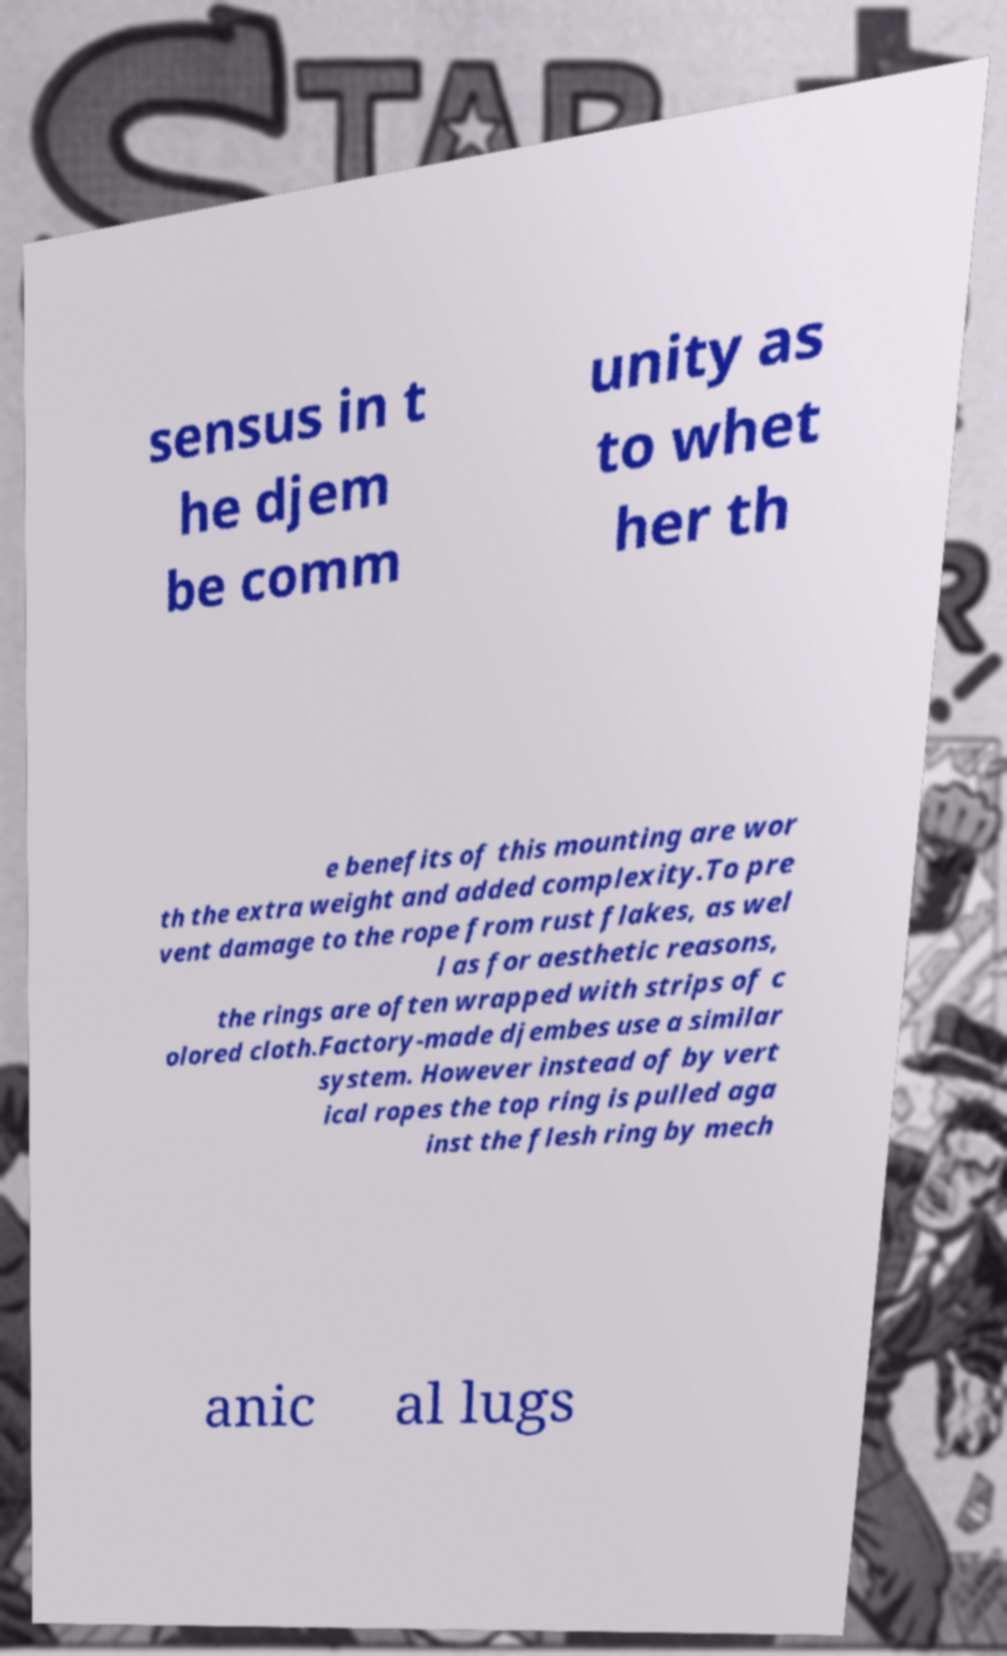Could you assist in decoding the text presented in this image and type it out clearly? sensus in t he djem be comm unity as to whet her th e benefits of this mounting are wor th the extra weight and added complexity.To pre vent damage to the rope from rust flakes, as wel l as for aesthetic reasons, the rings are often wrapped with strips of c olored cloth.Factory-made djembes use a similar system. However instead of by vert ical ropes the top ring is pulled aga inst the flesh ring by mech anic al lugs 